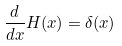Convert formula to latex. <formula><loc_0><loc_0><loc_500><loc_500>\frac { d } { d x } H ( x ) = \delta ( x )</formula> 